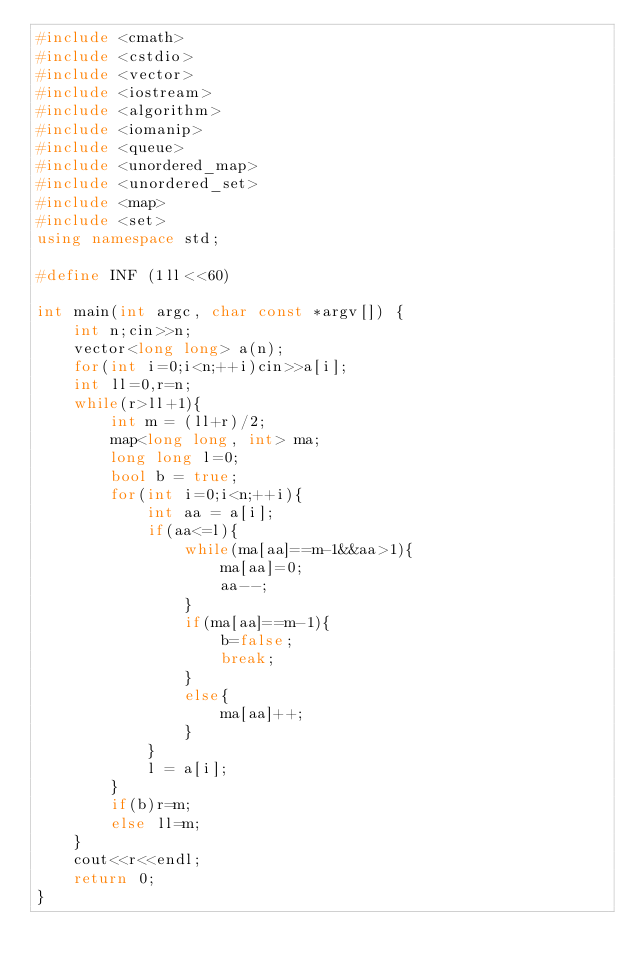Convert code to text. <code><loc_0><loc_0><loc_500><loc_500><_C++_>#include <cmath>
#include <cstdio>
#include <vector>
#include <iostream>
#include <algorithm>
#include <iomanip>
#include <queue>
#include <unordered_map>
#include <unordered_set>
#include <map>
#include <set>
using namespace std;

#define INF (1ll<<60)

int main(int argc, char const *argv[]) {
    int n;cin>>n;
    vector<long long> a(n);
    for(int i=0;i<n;++i)cin>>a[i];
    int ll=0,r=n;
    while(r>ll+1){
        int m = (ll+r)/2;
        map<long long, int> ma;
        long long l=0;
        bool b = true;
        for(int i=0;i<n;++i){
            int aa = a[i];
            if(aa<=l){
                while(ma[aa]==m-1&&aa>1){
                    ma[aa]=0;
                    aa--;
                }
                if(ma[aa]==m-1){
                    b=false;
                    break;
                }
                else{
                    ma[aa]++;
                }
            }
            l = a[i];
        }
        if(b)r=m;
        else ll=m;
    }
    cout<<r<<endl;
    return 0;
}</code> 